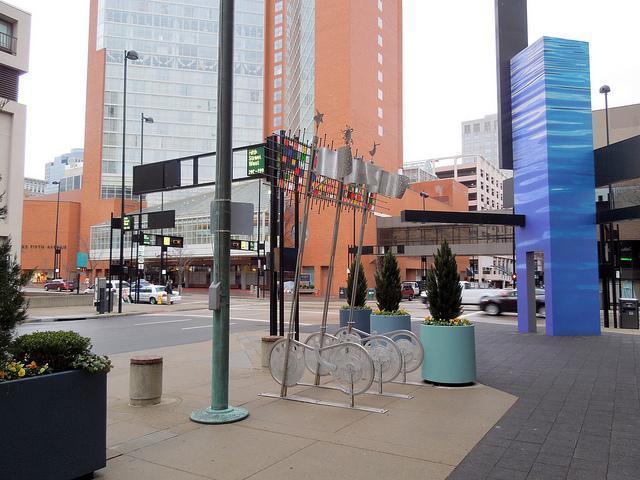How many potted plants can you see?
Give a very brief answer. 3. 